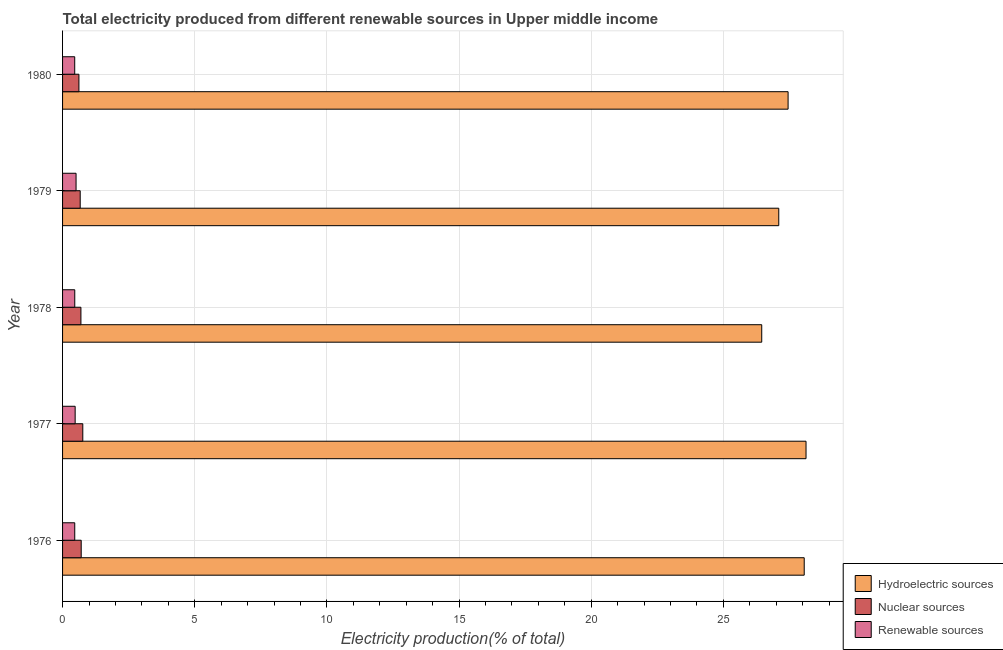Are the number of bars per tick equal to the number of legend labels?
Your answer should be compact. Yes. How many bars are there on the 5th tick from the top?
Keep it short and to the point. 3. What is the label of the 5th group of bars from the top?
Provide a short and direct response. 1976. What is the percentage of electricity produced by hydroelectric sources in 1980?
Your answer should be compact. 27.45. Across all years, what is the maximum percentage of electricity produced by nuclear sources?
Provide a succinct answer. 0.77. Across all years, what is the minimum percentage of electricity produced by nuclear sources?
Provide a succinct answer. 0.62. In which year was the percentage of electricity produced by renewable sources minimum?
Your answer should be very brief. 1980. What is the total percentage of electricity produced by hydroelectric sources in the graph?
Offer a terse response. 137.18. What is the difference between the percentage of electricity produced by nuclear sources in 1976 and that in 1979?
Your answer should be very brief. 0.04. What is the difference between the percentage of electricity produced by renewable sources in 1976 and the percentage of electricity produced by hydroelectric sources in 1980?
Make the answer very short. -26.99. What is the average percentage of electricity produced by hydroelectric sources per year?
Offer a very short reply. 27.44. In the year 1980, what is the difference between the percentage of electricity produced by nuclear sources and percentage of electricity produced by hydroelectric sources?
Provide a short and direct response. -26.83. What is the ratio of the percentage of electricity produced by hydroelectric sources in 1977 to that in 1979?
Provide a succinct answer. 1.04. Is the difference between the percentage of electricity produced by renewable sources in 1976 and 1978 greater than the difference between the percentage of electricity produced by hydroelectric sources in 1976 and 1978?
Ensure brevity in your answer.  No. What is the difference between the highest and the second highest percentage of electricity produced by renewable sources?
Your answer should be very brief. 0.03. What is the difference between the highest and the lowest percentage of electricity produced by nuclear sources?
Offer a very short reply. 0.15. In how many years, is the percentage of electricity produced by nuclear sources greater than the average percentage of electricity produced by nuclear sources taken over all years?
Ensure brevity in your answer.  3. What does the 1st bar from the top in 1980 represents?
Make the answer very short. Renewable sources. What does the 2nd bar from the bottom in 1976 represents?
Offer a very short reply. Nuclear sources. Is it the case that in every year, the sum of the percentage of electricity produced by hydroelectric sources and percentage of electricity produced by nuclear sources is greater than the percentage of electricity produced by renewable sources?
Your response must be concise. Yes. How many bars are there?
Ensure brevity in your answer.  15. Are all the bars in the graph horizontal?
Give a very brief answer. Yes. How many years are there in the graph?
Provide a short and direct response. 5. Does the graph contain grids?
Offer a very short reply. Yes. What is the title of the graph?
Offer a terse response. Total electricity produced from different renewable sources in Upper middle income. Does "Resident buildings and public services" appear as one of the legend labels in the graph?
Your answer should be compact. No. What is the label or title of the X-axis?
Ensure brevity in your answer.  Electricity production(% of total). What is the Electricity production(% of total) in Hydroelectric sources in 1976?
Your answer should be compact. 28.06. What is the Electricity production(% of total) of Nuclear sources in 1976?
Give a very brief answer. 0.71. What is the Electricity production(% of total) in Renewable sources in 1976?
Offer a very short reply. 0.46. What is the Electricity production(% of total) in Hydroelectric sources in 1977?
Keep it short and to the point. 28.13. What is the Electricity production(% of total) in Nuclear sources in 1977?
Your answer should be very brief. 0.77. What is the Electricity production(% of total) of Renewable sources in 1977?
Offer a terse response. 0.48. What is the Electricity production(% of total) in Hydroelectric sources in 1978?
Make the answer very short. 26.45. What is the Electricity production(% of total) in Nuclear sources in 1978?
Offer a terse response. 0.69. What is the Electricity production(% of total) in Renewable sources in 1978?
Your response must be concise. 0.46. What is the Electricity production(% of total) of Hydroelectric sources in 1979?
Your response must be concise. 27.09. What is the Electricity production(% of total) of Nuclear sources in 1979?
Your answer should be very brief. 0.67. What is the Electricity production(% of total) of Renewable sources in 1979?
Give a very brief answer. 0.51. What is the Electricity production(% of total) in Hydroelectric sources in 1980?
Ensure brevity in your answer.  27.45. What is the Electricity production(% of total) of Nuclear sources in 1980?
Your response must be concise. 0.62. What is the Electricity production(% of total) in Renewable sources in 1980?
Provide a succinct answer. 0.46. Across all years, what is the maximum Electricity production(% of total) of Hydroelectric sources?
Offer a terse response. 28.13. Across all years, what is the maximum Electricity production(% of total) of Nuclear sources?
Make the answer very short. 0.77. Across all years, what is the maximum Electricity production(% of total) in Renewable sources?
Your answer should be compact. 0.51. Across all years, what is the minimum Electricity production(% of total) in Hydroelectric sources?
Ensure brevity in your answer.  26.45. Across all years, what is the minimum Electricity production(% of total) of Nuclear sources?
Keep it short and to the point. 0.62. Across all years, what is the minimum Electricity production(% of total) in Renewable sources?
Your response must be concise. 0.46. What is the total Electricity production(% of total) of Hydroelectric sources in the graph?
Provide a succinct answer. 137.18. What is the total Electricity production(% of total) in Nuclear sources in the graph?
Offer a terse response. 3.45. What is the total Electricity production(% of total) of Renewable sources in the graph?
Your answer should be compact. 2.37. What is the difference between the Electricity production(% of total) in Hydroelectric sources in 1976 and that in 1977?
Give a very brief answer. -0.07. What is the difference between the Electricity production(% of total) of Nuclear sources in 1976 and that in 1977?
Your answer should be compact. -0.06. What is the difference between the Electricity production(% of total) of Renewable sources in 1976 and that in 1977?
Offer a terse response. -0.02. What is the difference between the Electricity production(% of total) of Hydroelectric sources in 1976 and that in 1978?
Provide a succinct answer. 1.61. What is the difference between the Electricity production(% of total) of Nuclear sources in 1976 and that in 1978?
Give a very brief answer. 0.01. What is the difference between the Electricity production(% of total) of Renewable sources in 1976 and that in 1978?
Keep it short and to the point. -0. What is the difference between the Electricity production(% of total) in Hydroelectric sources in 1976 and that in 1979?
Ensure brevity in your answer.  0.96. What is the difference between the Electricity production(% of total) in Nuclear sources in 1976 and that in 1979?
Your answer should be compact. 0.04. What is the difference between the Electricity production(% of total) of Renewable sources in 1976 and that in 1979?
Make the answer very short. -0.05. What is the difference between the Electricity production(% of total) in Hydroelectric sources in 1976 and that in 1980?
Provide a succinct answer. 0.61. What is the difference between the Electricity production(% of total) in Nuclear sources in 1976 and that in 1980?
Provide a short and direct response. 0.09. What is the difference between the Electricity production(% of total) of Renewable sources in 1976 and that in 1980?
Offer a terse response. 0. What is the difference between the Electricity production(% of total) of Hydroelectric sources in 1977 and that in 1978?
Your response must be concise. 1.68. What is the difference between the Electricity production(% of total) of Nuclear sources in 1977 and that in 1978?
Provide a succinct answer. 0.07. What is the difference between the Electricity production(% of total) of Renewable sources in 1977 and that in 1978?
Ensure brevity in your answer.  0.01. What is the difference between the Electricity production(% of total) in Hydroelectric sources in 1977 and that in 1979?
Offer a very short reply. 1.03. What is the difference between the Electricity production(% of total) in Nuclear sources in 1977 and that in 1979?
Ensure brevity in your answer.  0.1. What is the difference between the Electricity production(% of total) in Renewable sources in 1977 and that in 1979?
Your answer should be compact. -0.03. What is the difference between the Electricity production(% of total) of Hydroelectric sources in 1977 and that in 1980?
Provide a succinct answer. 0.68. What is the difference between the Electricity production(% of total) in Nuclear sources in 1977 and that in 1980?
Make the answer very short. 0.15. What is the difference between the Electricity production(% of total) of Renewable sources in 1977 and that in 1980?
Give a very brief answer. 0.02. What is the difference between the Electricity production(% of total) of Hydroelectric sources in 1978 and that in 1979?
Make the answer very short. -0.64. What is the difference between the Electricity production(% of total) of Nuclear sources in 1978 and that in 1979?
Provide a short and direct response. 0.03. What is the difference between the Electricity production(% of total) in Renewable sources in 1978 and that in 1979?
Provide a succinct answer. -0.05. What is the difference between the Electricity production(% of total) in Hydroelectric sources in 1978 and that in 1980?
Ensure brevity in your answer.  -1. What is the difference between the Electricity production(% of total) of Nuclear sources in 1978 and that in 1980?
Provide a short and direct response. 0.08. What is the difference between the Electricity production(% of total) in Renewable sources in 1978 and that in 1980?
Your answer should be very brief. 0. What is the difference between the Electricity production(% of total) in Hydroelectric sources in 1979 and that in 1980?
Your answer should be compact. -0.35. What is the difference between the Electricity production(% of total) in Nuclear sources in 1979 and that in 1980?
Offer a very short reply. 0.05. What is the difference between the Electricity production(% of total) of Renewable sources in 1979 and that in 1980?
Give a very brief answer. 0.05. What is the difference between the Electricity production(% of total) of Hydroelectric sources in 1976 and the Electricity production(% of total) of Nuclear sources in 1977?
Give a very brief answer. 27.29. What is the difference between the Electricity production(% of total) in Hydroelectric sources in 1976 and the Electricity production(% of total) in Renewable sources in 1977?
Provide a succinct answer. 27.58. What is the difference between the Electricity production(% of total) in Nuclear sources in 1976 and the Electricity production(% of total) in Renewable sources in 1977?
Your answer should be compact. 0.23. What is the difference between the Electricity production(% of total) in Hydroelectric sources in 1976 and the Electricity production(% of total) in Nuclear sources in 1978?
Give a very brief answer. 27.36. What is the difference between the Electricity production(% of total) in Hydroelectric sources in 1976 and the Electricity production(% of total) in Renewable sources in 1978?
Your answer should be very brief. 27.6. What is the difference between the Electricity production(% of total) in Nuclear sources in 1976 and the Electricity production(% of total) in Renewable sources in 1978?
Make the answer very short. 0.24. What is the difference between the Electricity production(% of total) of Hydroelectric sources in 1976 and the Electricity production(% of total) of Nuclear sources in 1979?
Ensure brevity in your answer.  27.39. What is the difference between the Electricity production(% of total) in Hydroelectric sources in 1976 and the Electricity production(% of total) in Renewable sources in 1979?
Your answer should be very brief. 27.55. What is the difference between the Electricity production(% of total) in Nuclear sources in 1976 and the Electricity production(% of total) in Renewable sources in 1979?
Provide a short and direct response. 0.19. What is the difference between the Electricity production(% of total) of Hydroelectric sources in 1976 and the Electricity production(% of total) of Nuclear sources in 1980?
Give a very brief answer. 27.44. What is the difference between the Electricity production(% of total) of Hydroelectric sources in 1976 and the Electricity production(% of total) of Renewable sources in 1980?
Give a very brief answer. 27.6. What is the difference between the Electricity production(% of total) in Nuclear sources in 1976 and the Electricity production(% of total) in Renewable sources in 1980?
Your answer should be compact. 0.25. What is the difference between the Electricity production(% of total) of Hydroelectric sources in 1977 and the Electricity production(% of total) of Nuclear sources in 1978?
Provide a succinct answer. 27.43. What is the difference between the Electricity production(% of total) in Hydroelectric sources in 1977 and the Electricity production(% of total) in Renewable sources in 1978?
Provide a succinct answer. 27.67. What is the difference between the Electricity production(% of total) in Nuclear sources in 1977 and the Electricity production(% of total) in Renewable sources in 1978?
Keep it short and to the point. 0.3. What is the difference between the Electricity production(% of total) of Hydroelectric sources in 1977 and the Electricity production(% of total) of Nuclear sources in 1979?
Keep it short and to the point. 27.46. What is the difference between the Electricity production(% of total) in Hydroelectric sources in 1977 and the Electricity production(% of total) in Renewable sources in 1979?
Offer a terse response. 27.62. What is the difference between the Electricity production(% of total) in Nuclear sources in 1977 and the Electricity production(% of total) in Renewable sources in 1979?
Provide a short and direct response. 0.25. What is the difference between the Electricity production(% of total) of Hydroelectric sources in 1977 and the Electricity production(% of total) of Nuclear sources in 1980?
Provide a short and direct response. 27.51. What is the difference between the Electricity production(% of total) of Hydroelectric sources in 1977 and the Electricity production(% of total) of Renewable sources in 1980?
Your response must be concise. 27.67. What is the difference between the Electricity production(% of total) of Nuclear sources in 1977 and the Electricity production(% of total) of Renewable sources in 1980?
Offer a very short reply. 0.31. What is the difference between the Electricity production(% of total) in Hydroelectric sources in 1978 and the Electricity production(% of total) in Nuclear sources in 1979?
Give a very brief answer. 25.78. What is the difference between the Electricity production(% of total) in Hydroelectric sources in 1978 and the Electricity production(% of total) in Renewable sources in 1979?
Ensure brevity in your answer.  25.94. What is the difference between the Electricity production(% of total) of Nuclear sources in 1978 and the Electricity production(% of total) of Renewable sources in 1979?
Provide a succinct answer. 0.18. What is the difference between the Electricity production(% of total) in Hydroelectric sources in 1978 and the Electricity production(% of total) in Nuclear sources in 1980?
Offer a terse response. 25.83. What is the difference between the Electricity production(% of total) of Hydroelectric sources in 1978 and the Electricity production(% of total) of Renewable sources in 1980?
Your answer should be very brief. 25.99. What is the difference between the Electricity production(% of total) in Nuclear sources in 1978 and the Electricity production(% of total) in Renewable sources in 1980?
Ensure brevity in your answer.  0.23. What is the difference between the Electricity production(% of total) of Hydroelectric sources in 1979 and the Electricity production(% of total) of Nuclear sources in 1980?
Offer a terse response. 26.48. What is the difference between the Electricity production(% of total) in Hydroelectric sources in 1979 and the Electricity production(% of total) in Renewable sources in 1980?
Make the answer very short. 26.64. What is the difference between the Electricity production(% of total) of Nuclear sources in 1979 and the Electricity production(% of total) of Renewable sources in 1980?
Offer a terse response. 0.21. What is the average Electricity production(% of total) of Hydroelectric sources per year?
Provide a short and direct response. 27.44. What is the average Electricity production(% of total) of Nuclear sources per year?
Give a very brief answer. 0.69. What is the average Electricity production(% of total) in Renewable sources per year?
Your response must be concise. 0.47. In the year 1976, what is the difference between the Electricity production(% of total) of Hydroelectric sources and Electricity production(% of total) of Nuclear sources?
Keep it short and to the point. 27.35. In the year 1976, what is the difference between the Electricity production(% of total) of Hydroelectric sources and Electricity production(% of total) of Renewable sources?
Your answer should be compact. 27.6. In the year 1976, what is the difference between the Electricity production(% of total) in Nuclear sources and Electricity production(% of total) in Renewable sources?
Offer a terse response. 0.24. In the year 1977, what is the difference between the Electricity production(% of total) in Hydroelectric sources and Electricity production(% of total) in Nuclear sources?
Keep it short and to the point. 27.36. In the year 1977, what is the difference between the Electricity production(% of total) of Hydroelectric sources and Electricity production(% of total) of Renewable sources?
Offer a very short reply. 27.65. In the year 1977, what is the difference between the Electricity production(% of total) of Nuclear sources and Electricity production(% of total) of Renewable sources?
Your answer should be very brief. 0.29. In the year 1978, what is the difference between the Electricity production(% of total) in Hydroelectric sources and Electricity production(% of total) in Nuclear sources?
Offer a terse response. 25.76. In the year 1978, what is the difference between the Electricity production(% of total) of Hydroelectric sources and Electricity production(% of total) of Renewable sources?
Give a very brief answer. 25.99. In the year 1978, what is the difference between the Electricity production(% of total) of Nuclear sources and Electricity production(% of total) of Renewable sources?
Provide a succinct answer. 0.23. In the year 1979, what is the difference between the Electricity production(% of total) of Hydroelectric sources and Electricity production(% of total) of Nuclear sources?
Make the answer very short. 26.43. In the year 1979, what is the difference between the Electricity production(% of total) in Hydroelectric sources and Electricity production(% of total) in Renewable sources?
Your answer should be very brief. 26.58. In the year 1979, what is the difference between the Electricity production(% of total) of Nuclear sources and Electricity production(% of total) of Renewable sources?
Offer a very short reply. 0.16. In the year 1980, what is the difference between the Electricity production(% of total) of Hydroelectric sources and Electricity production(% of total) of Nuclear sources?
Give a very brief answer. 26.83. In the year 1980, what is the difference between the Electricity production(% of total) in Hydroelectric sources and Electricity production(% of total) in Renewable sources?
Give a very brief answer. 26.99. In the year 1980, what is the difference between the Electricity production(% of total) in Nuclear sources and Electricity production(% of total) in Renewable sources?
Your answer should be compact. 0.16. What is the ratio of the Electricity production(% of total) in Nuclear sources in 1976 to that in 1977?
Your answer should be very brief. 0.92. What is the ratio of the Electricity production(% of total) in Renewable sources in 1976 to that in 1977?
Make the answer very short. 0.97. What is the ratio of the Electricity production(% of total) of Hydroelectric sources in 1976 to that in 1978?
Provide a succinct answer. 1.06. What is the ratio of the Electricity production(% of total) in Nuclear sources in 1976 to that in 1978?
Your answer should be compact. 1.02. What is the ratio of the Electricity production(% of total) in Hydroelectric sources in 1976 to that in 1979?
Ensure brevity in your answer.  1.04. What is the ratio of the Electricity production(% of total) of Nuclear sources in 1976 to that in 1979?
Provide a succinct answer. 1.06. What is the ratio of the Electricity production(% of total) in Renewable sources in 1976 to that in 1979?
Offer a very short reply. 0.9. What is the ratio of the Electricity production(% of total) of Hydroelectric sources in 1976 to that in 1980?
Your answer should be compact. 1.02. What is the ratio of the Electricity production(% of total) in Nuclear sources in 1976 to that in 1980?
Your response must be concise. 1.14. What is the ratio of the Electricity production(% of total) in Renewable sources in 1976 to that in 1980?
Offer a very short reply. 1. What is the ratio of the Electricity production(% of total) in Hydroelectric sources in 1977 to that in 1978?
Make the answer very short. 1.06. What is the ratio of the Electricity production(% of total) in Nuclear sources in 1977 to that in 1978?
Offer a terse response. 1.1. What is the ratio of the Electricity production(% of total) in Renewable sources in 1977 to that in 1978?
Provide a succinct answer. 1.03. What is the ratio of the Electricity production(% of total) in Hydroelectric sources in 1977 to that in 1979?
Provide a short and direct response. 1.04. What is the ratio of the Electricity production(% of total) in Nuclear sources in 1977 to that in 1979?
Provide a succinct answer. 1.15. What is the ratio of the Electricity production(% of total) in Renewable sources in 1977 to that in 1979?
Ensure brevity in your answer.  0.93. What is the ratio of the Electricity production(% of total) of Hydroelectric sources in 1977 to that in 1980?
Give a very brief answer. 1.02. What is the ratio of the Electricity production(% of total) of Nuclear sources in 1977 to that in 1980?
Keep it short and to the point. 1.24. What is the ratio of the Electricity production(% of total) of Renewable sources in 1977 to that in 1980?
Your response must be concise. 1.04. What is the ratio of the Electricity production(% of total) of Hydroelectric sources in 1978 to that in 1979?
Your response must be concise. 0.98. What is the ratio of the Electricity production(% of total) of Nuclear sources in 1978 to that in 1979?
Keep it short and to the point. 1.04. What is the ratio of the Electricity production(% of total) of Renewable sources in 1978 to that in 1979?
Ensure brevity in your answer.  0.9. What is the ratio of the Electricity production(% of total) of Hydroelectric sources in 1978 to that in 1980?
Keep it short and to the point. 0.96. What is the ratio of the Electricity production(% of total) in Nuclear sources in 1978 to that in 1980?
Make the answer very short. 1.12. What is the ratio of the Electricity production(% of total) of Hydroelectric sources in 1979 to that in 1980?
Ensure brevity in your answer.  0.99. What is the ratio of the Electricity production(% of total) of Nuclear sources in 1979 to that in 1980?
Your answer should be very brief. 1.08. What is the ratio of the Electricity production(% of total) in Renewable sources in 1979 to that in 1980?
Provide a short and direct response. 1.11. What is the difference between the highest and the second highest Electricity production(% of total) in Hydroelectric sources?
Your response must be concise. 0.07. What is the difference between the highest and the second highest Electricity production(% of total) in Renewable sources?
Offer a very short reply. 0.03. What is the difference between the highest and the lowest Electricity production(% of total) of Hydroelectric sources?
Provide a succinct answer. 1.68. What is the difference between the highest and the lowest Electricity production(% of total) in Nuclear sources?
Your answer should be very brief. 0.15. What is the difference between the highest and the lowest Electricity production(% of total) of Renewable sources?
Give a very brief answer. 0.05. 